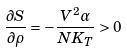Convert formula to latex. <formula><loc_0><loc_0><loc_500><loc_500>\frac { \partial S } { \partial \rho } = - \frac { V ^ { 2 } \alpha } { N K _ { T } } > 0</formula> 